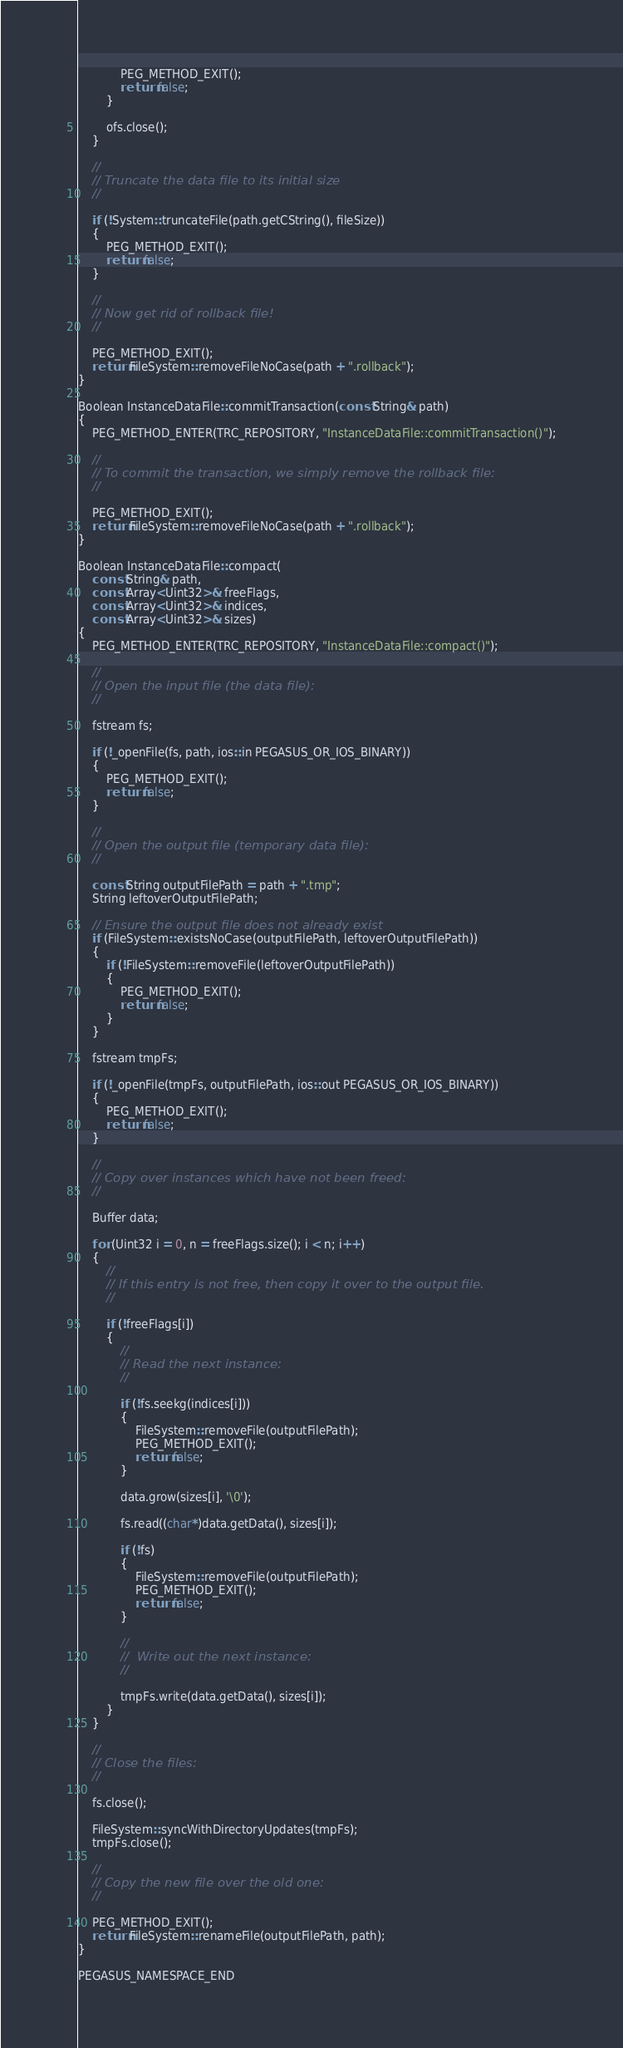<code> <loc_0><loc_0><loc_500><loc_500><_C++_>            PEG_METHOD_EXIT();
            return false;
        }

        ofs.close();
    }

    //
    // Truncate the data file to its initial size
    //

    if (!System::truncateFile(path.getCString(), fileSize))
    {
        PEG_METHOD_EXIT();
        return false;
    }

    //
    // Now get rid of rollback file!
    //

    PEG_METHOD_EXIT();
    return FileSystem::removeFileNoCase(path + ".rollback");
}

Boolean InstanceDataFile::commitTransaction(const String& path)
{
    PEG_METHOD_ENTER(TRC_REPOSITORY, "InstanceDataFile::commitTransaction()");

    //
    // To commit the transaction, we simply remove the rollback file:
    //

    PEG_METHOD_EXIT();
    return FileSystem::removeFileNoCase(path + ".rollback");
}

Boolean InstanceDataFile::compact(
    const String& path,
    const Array<Uint32>& freeFlags,
    const Array<Uint32>& indices,
    const Array<Uint32>& sizes)
{
    PEG_METHOD_ENTER(TRC_REPOSITORY, "InstanceDataFile::compact()");

    //
    // Open the input file (the data file):
    //

    fstream fs;

    if (!_openFile(fs, path, ios::in PEGASUS_OR_IOS_BINARY))
    {
        PEG_METHOD_EXIT();
        return false;
    }

    //
    // Open the output file (temporary data file):
    //

    const String outputFilePath = path + ".tmp";
    String leftoverOutputFilePath;

    // Ensure the output file does not already exist
    if (FileSystem::existsNoCase(outputFilePath, leftoverOutputFilePath))
    {
        if (!FileSystem::removeFile(leftoverOutputFilePath))
        {
            PEG_METHOD_EXIT();
            return false;
        }
    }

    fstream tmpFs;

    if (!_openFile(tmpFs, outputFilePath, ios::out PEGASUS_OR_IOS_BINARY))
    {
        PEG_METHOD_EXIT();
        return false;
    }

    //
    // Copy over instances which have not been freed:
    //

    Buffer data;

    for (Uint32 i = 0, n = freeFlags.size(); i < n; i++)
    {
        //
        // If this entry is not free, then copy it over to the output file.
        //

        if (!freeFlags[i])
        {
            //
            // Read the next instance:
            //

            if (!fs.seekg(indices[i]))
            {
                FileSystem::removeFile(outputFilePath);
                PEG_METHOD_EXIT();
                return false;
            }

            data.grow(sizes[i], '\0');

            fs.read((char*)data.getData(), sizes[i]);

            if (!fs)
            {
                FileSystem::removeFile(outputFilePath);
                PEG_METHOD_EXIT();
                return false;
            }

            //
            //  Write out the next instance:
            //

            tmpFs.write(data.getData(), sizes[i]);
        }
    }

    //
    // Close the files:
    //

    fs.close();

    FileSystem::syncWithDirectoryUpdates(tmpFs);
    tmpFs.close();

    //
    // Copy the new file over the old one:
    //

    PEG_METHOD_EXIT();
    return FileSystem::renameFile(outputFilePath, path);
}

PEGASUS_NAMESPACE_END
</code> 